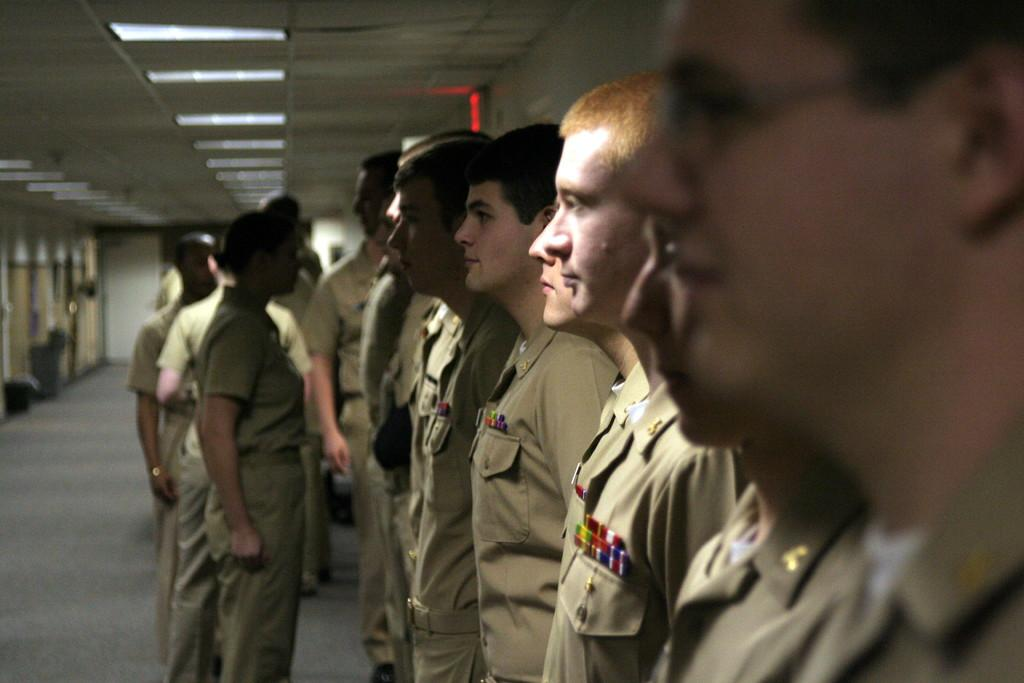What can be seen on the right side of the image? There are people standing on the right side of the image. What are the people wearing? The people are wearing uniforms. What is located on the left side of the image? There are rooms on the left side of the image. What feature can be observed in the rooms? Lights are attached to the ceiling in the rooms. Can you tell me how many lamps are present in the image? There is no mention of lamps in the image; the provided facts only mention lights attached to the ceiling in the rooms. What story is being told by the people standing on the right side of the image? There is no indication of a story being told in the image; the people are simply standing and wearing uniforms. 